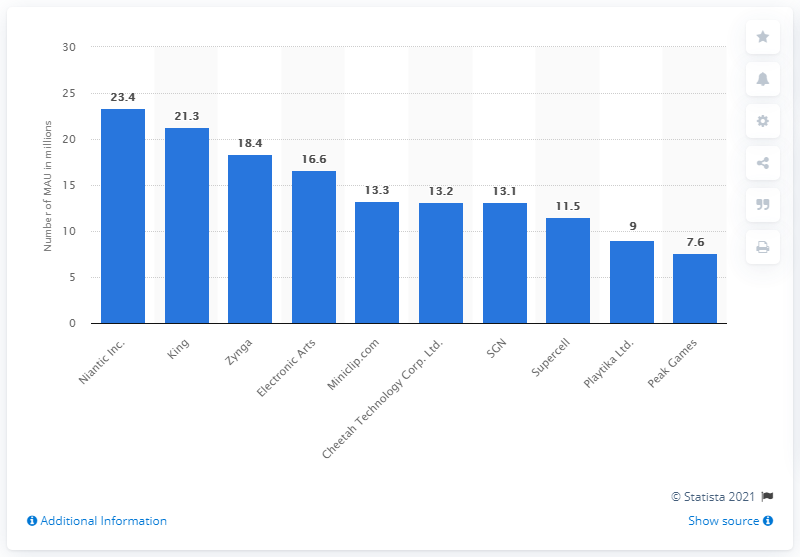Indicate a few pertinent items in this graphic. Zynga was the third most popular mobile games publisher. 